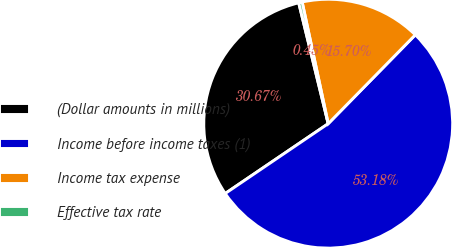<chart> <loc_0><loc_0><loc_500><loc_500><pie_chart><fcel>(Dollar amounts in millions)<fcel>Income before income taxes (1)<fcel>Income tax expense<fcel>Effective tax rate<nl><fcel>30.67%<fcel>53.17%<fcel>15.7%<fcel>0.45%<nl></chart> 